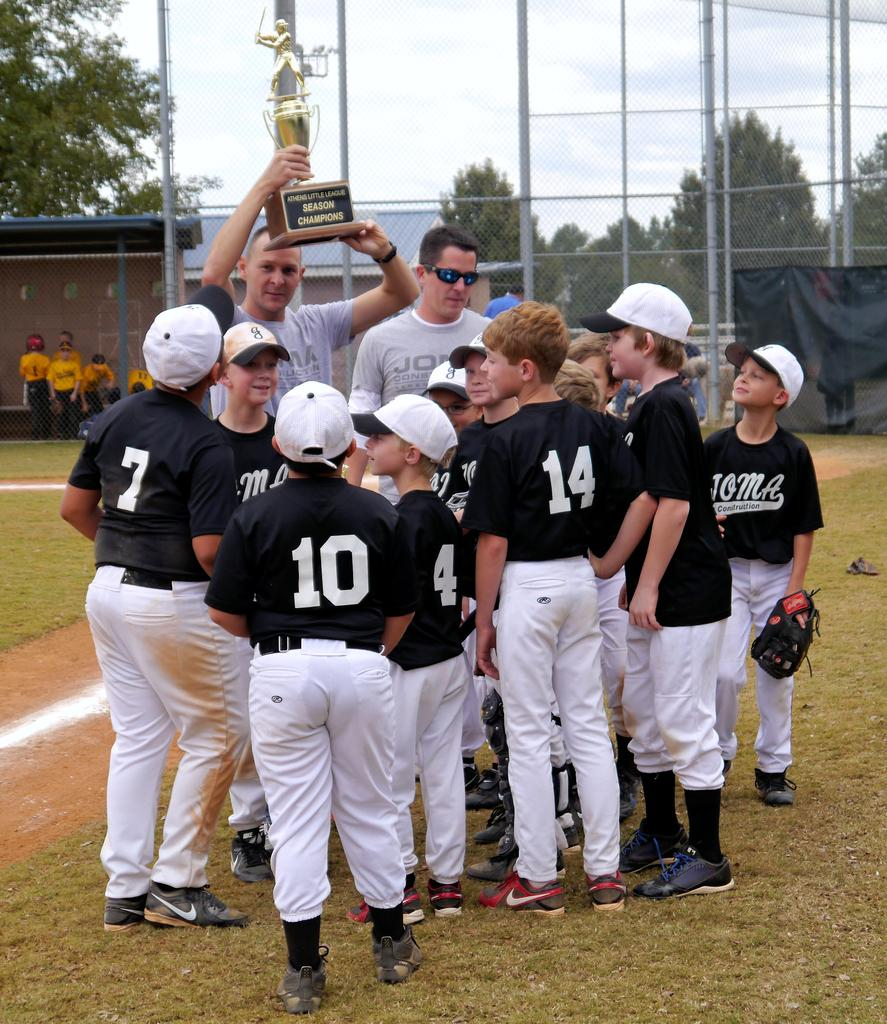<image>
Create a compact narrative representing the image presented. A kid in a uniform with the number 10 on it stands with his team. 